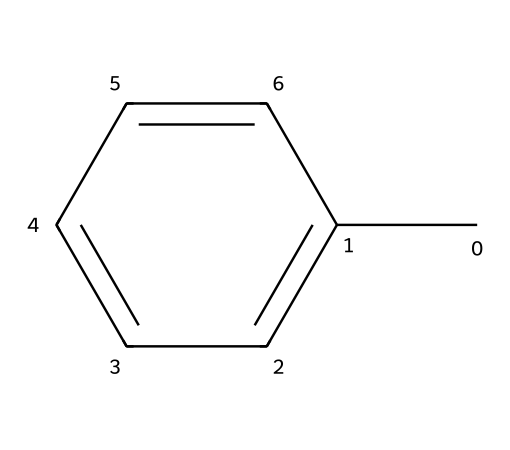What is the name of this chemical? The SMILES representation "Cc1ccccc1" describes toluene, which is known for its common use as a solvent in paints and paint thinners.
Answer: toluene How many carbon atoms are in toluene? In the SMILES, "Cc1ccccc1" shows a total of 7 carbon atoms: 6 in the aromatic ring and 1 as a methyl group.
Answer: 7 What is the number of hydrogen atoms in toluene? Each carbon in toluene, depending on its bonding, typically contributes hydrogen atoms. This structure has seven hydrogen atoms attached (one to each of the seven carbons).
Answer: 8 Does toluene have a double bond? The structure includes a benzene ring, which contains alternating double bonds between the carbon atoms, indicating it has double bonds.
Answer: yes What type of chemical is toluene classified as? Toluene is classified as an aromatic hydrocarbon due to its benzene ring structure, which is characteristic of aromatic compounds.
Answer: aromatic hydrocarbon What physical property of toluene contributes to its flammability? Toluene's low flash point (around 4 degrees Celsius) contributes to its flammability, making it easily ignitable at room temperature.
Answer: low flash point Why is toluene used in paint thinners? Toluene is effective in dissolving resins and polymers, which makes it ideal for thinners. Its solvent properties are crucial for thinning paint to achieve the desired viscosity.
Answer: solvent properties 